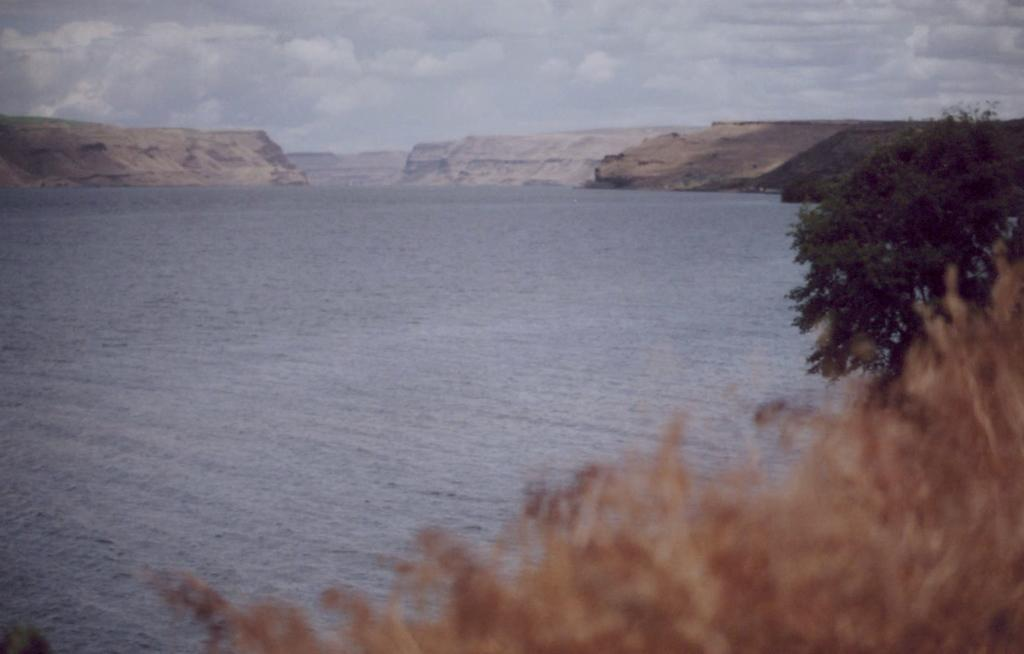What type of vegetation is present in the image? There is grass and trees in the image. What natural feature can be seen in the image? There is water in the image. What geographical feature is visible in the distance? There are mountains in the image. What part of the natural environment is visible in the image? The sky is visible in the image. Can you determine the time of day the image was taken? The image might have been taken during the day, based on the visibility of the sky and the presence of sunlight. What type of juice can be seen in the image? There is no juice present in the image. 